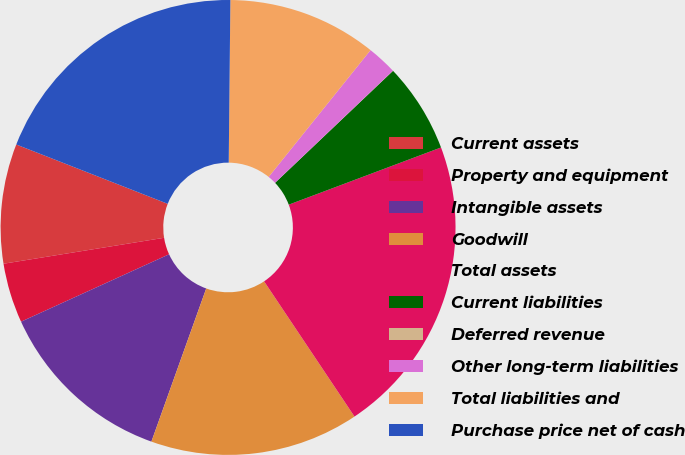Convert chart. <chart><loc_0><loc_0><loc_500><loc_500><pie_chart><fcel>Current assets<fcel>Property and equipment<fcel>Intangible assets<fcel>Goodwill<fcel>Total assets<fcel>Current liabilities<fcel>Deferred revenue<fcel>Other long-term liabilities<fcel>Total liabilities and<fcel>Purchase price net of cash<nl><fcel>8.49%<fcel>4.25%<fcel>12.73%<fcel>14.85%<fcel>21.34%<fcel>6.37%<fcel>0.01%<fcel>2.13%<fcel>10.61%<fcel>19.22%<nl></chart> 